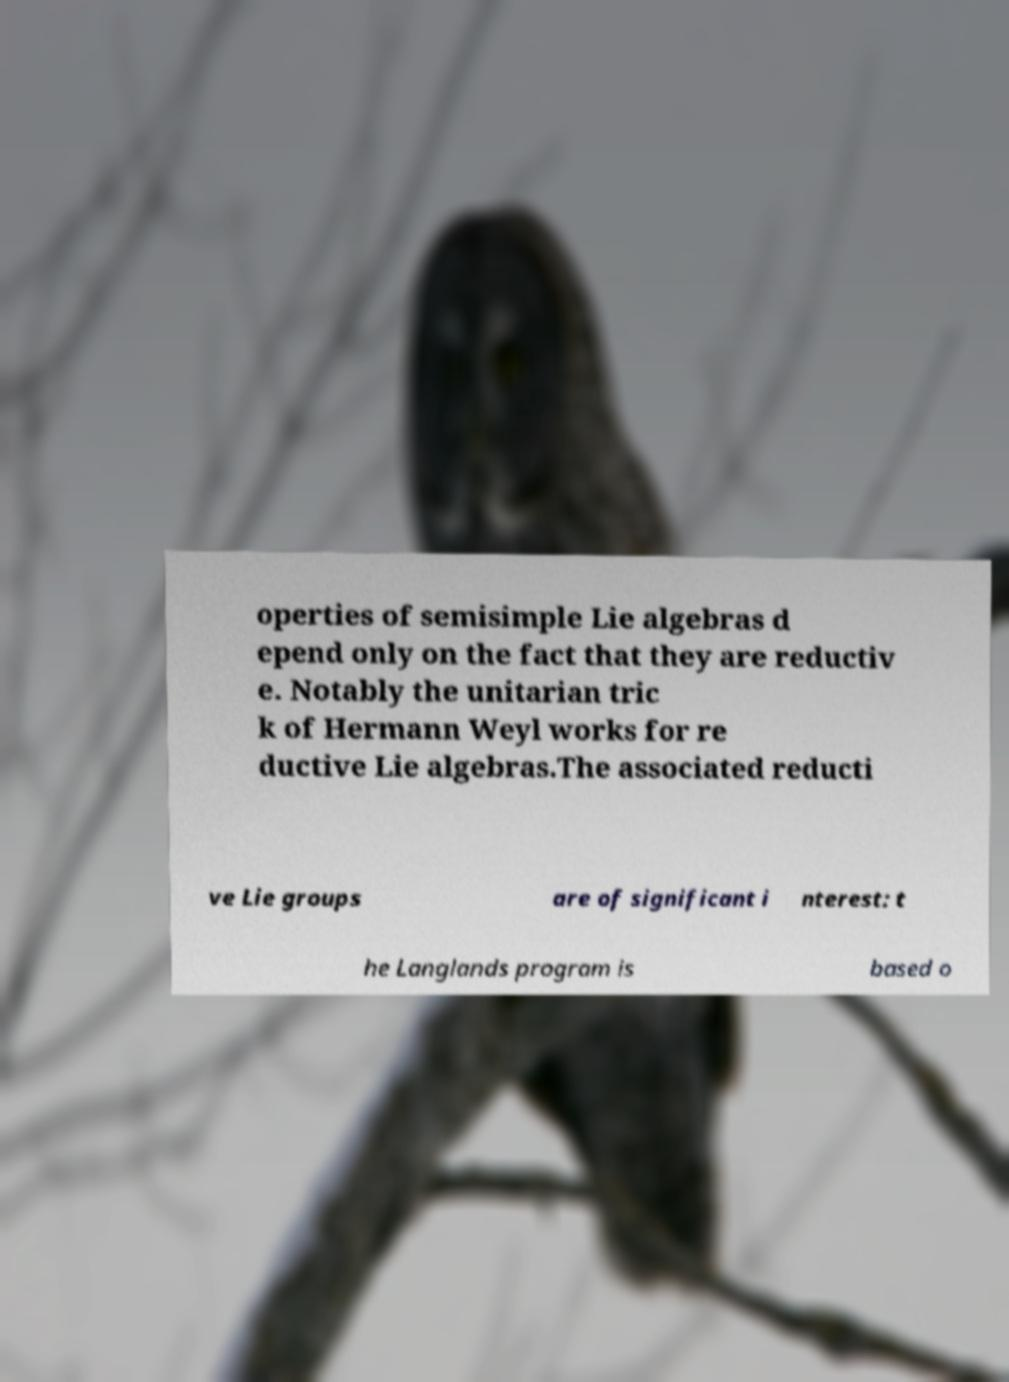Please identify and transcribe the text found in this image. operties of semisimple Lie algebras d epend only on the fact that they are reductiv e. Notably the unitarian tric k of Hermann Weyl works for re ductive Lie algebras.The associated reducti ve Lie groups are of significant i nterest: t he Langlands program is based o 